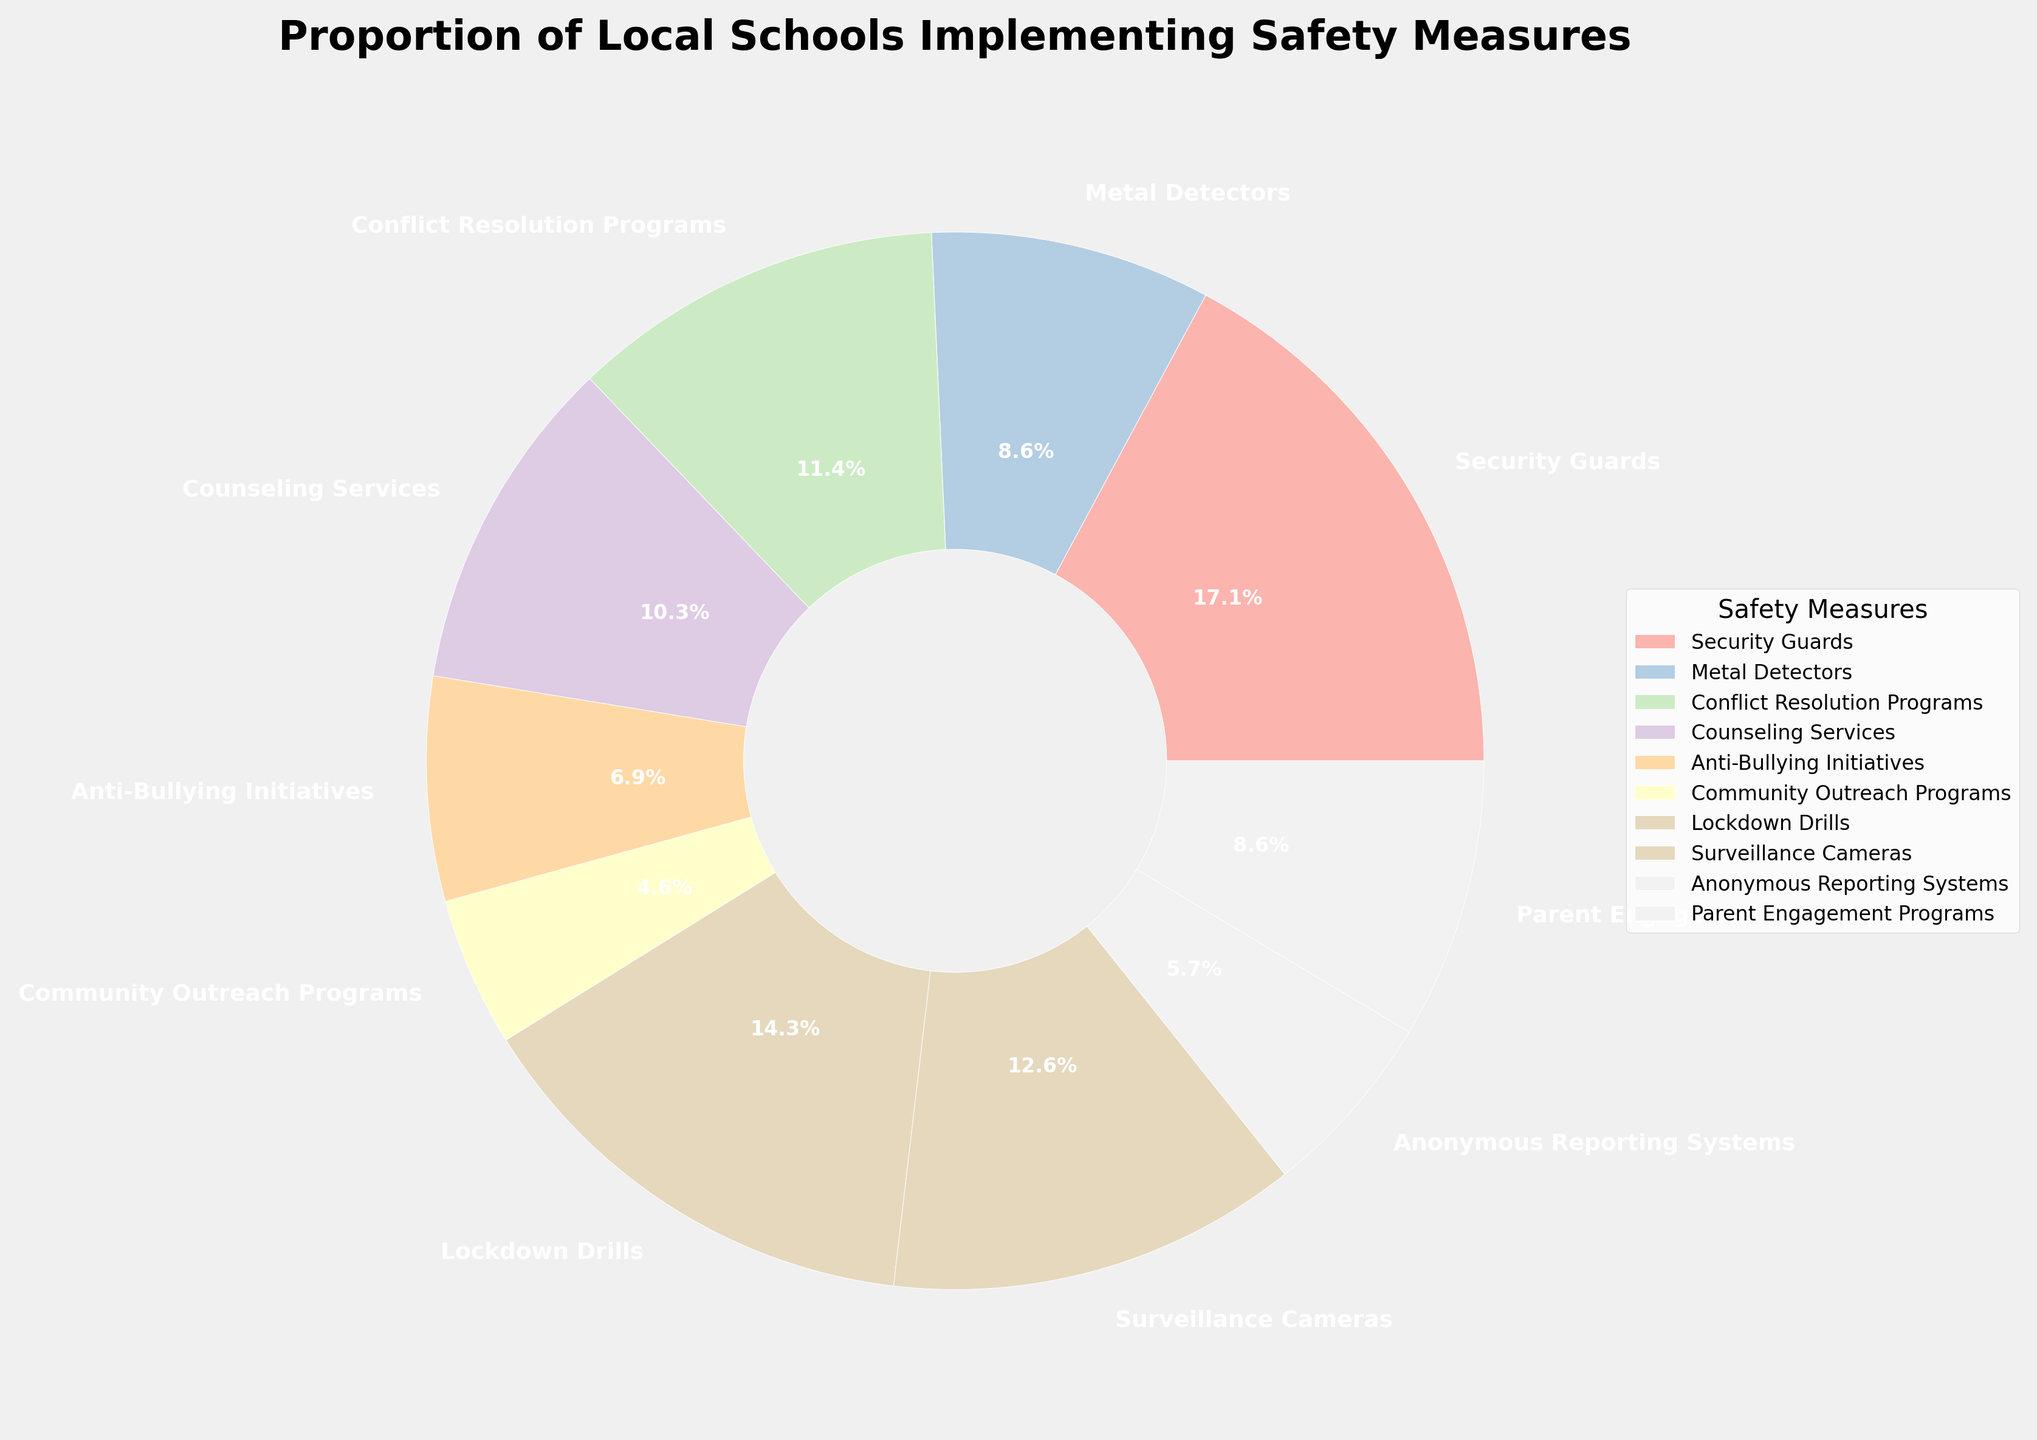Which safety measure is implemented by the largest proportion of schools? The pie chart shows that "Security Guards" occupies the largest segment of the pie, labeled with 30%.
Answer: Security Guards Which safety measure is implemented by the smallest proportion of schools? According to the pie chart, the smallest segment is labeled "Community Outreach Programs" with a percentage of 8%.
Answer: Community Outreach Programs How much more common are security guards compared to surveillance cameras? Security Guards are implemented by 30% of schools while Surveillance Cameras are implemented by 22%. The difference is 30% - 22% = 8%.
Answer: 8% What is the combined percentage of schools implementing counseling services and anti-bullying initiatives? Counseling Services are implemented by 18% of schools and Anti-Bullying Initiatives by 12%. Adding these gives 18% + 12% = 30%.
Answer: 30% Which safety measures are implemented by an equal percentage of schools? The pie chart shows that Metal Detectors and Parent Engagement Programs are each implemented by 15% of schools.
Answer: Metal Detectors and Parent Engagement Programs What is the percentage difference between schools implementing conflict resolution programs and anonymous reporting systems? Conflict Resolution Programs are implemented by 20% and Anonymous Reporting Systems by 10%. The difference is 20% - 10% = 10%.
Answer: 10% How many safety measures are implemented by less than 20% of schools each? By checking each segment of the pie chart, it can be observed that six safety measures (Metal Detectors, Counseling Services, Anti-Bullying Initiatives, Community Outreach Programs, Anonymous Reporting Systems, and Parent Engagement Programs) are implemented by less than 20% of schools each.
Answer: 6 Among the visual attributes, which safety measure has the second largest segment in the pie chart? After Security Guards, the next largest segment is for "Lockdown Drills" at 25%.
Answer: Lockdown Drills What's the average percentage of schools implementing metal detectors, counseling services, and parent engagement programs? Sum the percentages (15% for Metal Detectors + 18% for Counseling Services + 15% for Parent Engagement Programs) = 48%. The average is 48% / 3 = 16%.
Answer: 16% Which safety measures have nearly the same proportions, making them difficult to distinguish visually? Metal Detectors and Parent Engagement Programs both have 15%, while Conflict Resolution Programs with 20% and Surveillance Cameras with 22% have close proportions that may make them visually similar.
Answer: Metal Detectors and Parent Engagement Programs; Conflict Resolution Programs and Surveillance Cameras 